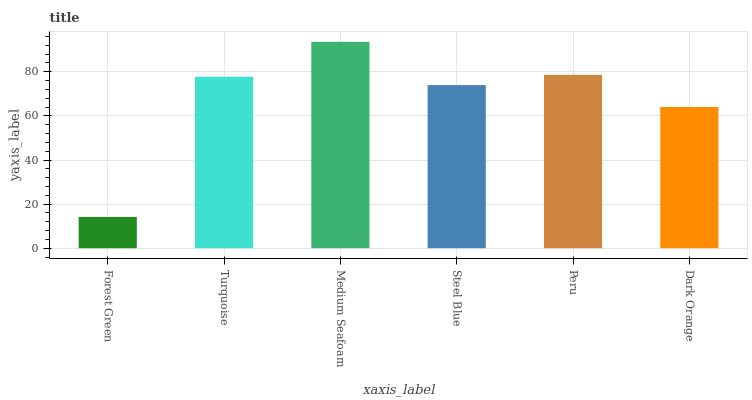Is Forest Green the minimum?
Answer yes or no. Yes. Is Medium Seafoam the maximum?
Answer yes or no. Yes. Is Turquoise the minimum?
Answer yes or no. No. Is Turquoise the maximum?
Answer yes or no. No. Is Turquoise greater than Forest Green?
Answer yes or no. Yes. Is Forest Green less than Turquoise?
Answer yes or no. Yes. Is Forest Green greater than Turquoise?
Answer yes or no. No. Is Turquoise less than Forest Green?
Answer yes or no. No. Is Turquoise the high median?
Answer yes or no. Yes. Is Steel Blue the low median?
Answer yes or no. Yes. Is Dark Orange the high median?
Answer yes or no. No. Is Forest Green the low median?
Answer yes or no. No. 